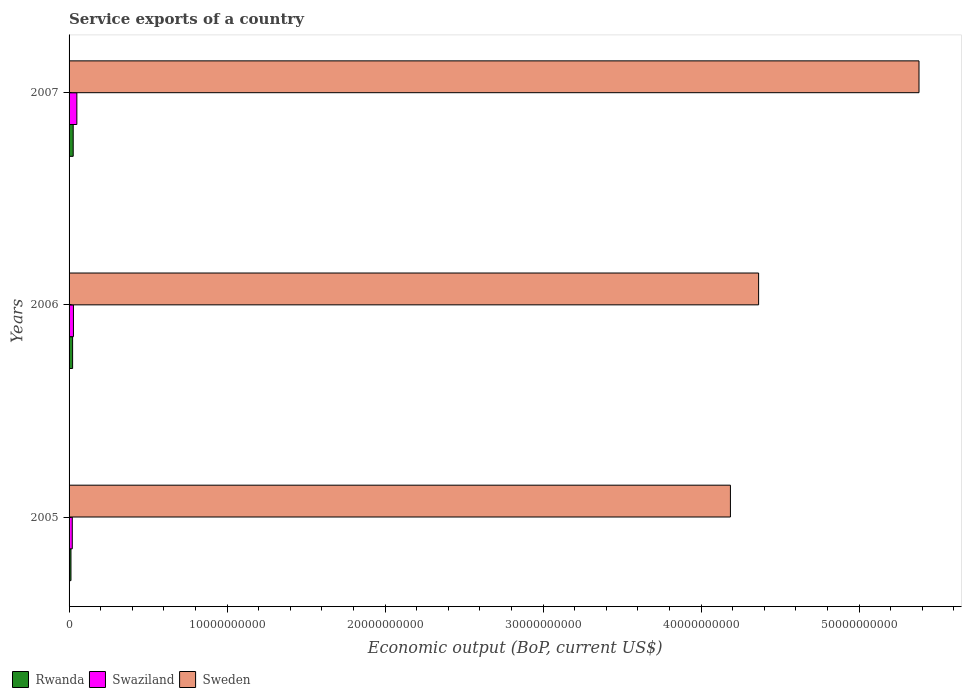How many bars are there on the 1st tick from the top?
Make the answer very short. 3. What is the label of the 2nd group of bars from the top?
Keep it short and to the point. 2006. What is the service exports in Swaziland in 2006?
Keep it short and to the point. 2.77e+08. Across all years, what is the maximum service exports in Swaziland?
Your answer should be very brief. 4.93e+08. Across all years, what is the minimum service exports in Sweden?
Provide a succinct answer. 4.19e+1. In which year was the service exports in Swaziland maximum?
Make the answer very short. 2007. In which year was the service exports in Sweden minimum?
Offer a very short reply. 2005. What is the total service exports in Rwanda in the graph?
Offer a very short reply. 6.06e+08. What is the difference between the service exports in Sweden in 2006 and that in 2007?
Keep it short and to the point. -1.02e+1. What is the difference between the service exports in Rwanda in 2006 and the service exports in Swaziland in 2005?
Give a very brief answer. 2.04e+07. What is the average service exports in Swaziland per year?
Keep it short and to the point. 3.25e+08. In the year 2006, what is the difference between the service exports in Swaziland and service exports in Rwanda?
Ensure brevity in your answer.  5.35e+07. In how many years, is the service exports in Rwanda greater than 26000000000 US$?
Your answer should be compact. 0. What is the ratio of the service exports in Sweden in 2005 to that in 2007?
Your answer should be compact. 0.78. Is the service exports in Rwanda in 2005 less than that in 2006?
Give a very brief answer. Yes. Is the difference between the service exports in Swaziland in 2006 and 2007 greater than the difference between the service exports in Rwanda in 2006 and 2007?
Your response must be concise. No. What is the difference between the highest and the second highest service exports in Sweden?
Offer a terse response. 1.02e+1. What is the difference between the highest and the lowest service exports in Rwanda?
Provide a succinct answer. 1.42e+08. What does the 3rd bar from the top in 2007 represents?
Ensure brevity in your answer.  Rwanda. Are all the bars in the graph horizontal?
Your answer should be compact. Yes. How many years are there in the graph?
Offer a terse response. 3. What is the difference between two consecutive major ticks on the X-axis?
Make the answer very short. 1.00e+1. Does the graph contain any zero values?
Ensure brevity in your answer.  No. Where does the legend appear in the graph?
Offer a very short reply. Bottom left. What is the title of the graph?
Your answer should be compact. Service exports of a country. Does "Other small states" appear as one of the legend labels in the graph?
Offer a very short reply. No. What is the label or title of the X-axis?
Your response must be concise. Economic output (BoP, current US$). What is the Economic output (BoP, current US$) of Rwanda in 2005?
Your response must be concise. 1.20e+08. What is the Economic output (BoP, current US$) of Swaziland in 2005?
Give a very brief answer. 2.03e+08. What is the Economic output (BoP, current US$) of Sweden in 2005?
Offer a very short reply. 4.19e+1. What is the Economic output (BoP, current US$) in Rwanda in 2006?
Your answer should be very brief. 2.24e+08. What is the Economic output (BoP, current US$) in Swaziland in 2006?
Provide a short and direct response. 2.77e+08. What is the Economic output (BoP, current US$) in Sweden in 2006?
Give a very brief answer. 4.36e+1. What is the Economic output (BoP, current US$) of Rwanda in 2007?
Provide a succinct answer. 2.62e+08. What is the Economic output (BoP, current US$) of Swaziland in 2007?
Provide a succinct answer. 4.93e+08. What is the Economic output (BoP, current US$) of Sweden in 2007?
Give a very brief answer. 5.38e+1. Across all years, what is the maximum Economic output (BoP, current US$) of Rwanda?
Your answer should be compact. 2.62e+08. Across all years, what is the maximum Economic output (BoP, current US$) in Swaziland?
Your response must be concise. 4.93e+08. Across all years, what is the maximum Economic output (BoP, current US$) of Sweden?
Your response must be concise. 5.38e+1. Across all years, what is the minimum Economic output (BoP, current US$) in Rwanda?
Ensure brevity in your answer.  1.20e+08. Across all years, what is the minimum Economic output (BoP, current US$) in Swaziland?
Offer a very short reply. 2.03e+08. Across all years, what is the minimum Economic output (BoP, current US$) of Sweden?
Your answer should be very brief. 4.19e+1. What is the total Economic output (BoP, current US$) of Rwanda in the graph?
Offer a terse response. 6.06e+08. What is the total Economic output (BoP, current US$) in Swaziland in the graph?
Offer a terse response. 9.74e+08. What is the total Economic output (BoP, current US$) in Sweden in the graph?
Provide a succinct answer. 1.39e+11. What is the difference between the Economic output (BoP, current US$) of Rwanda in 2005 and that in 2006?
Provide a succinct answer. -1.04e+08. What is the difference between the Economic output (BoP, current US$) in Swaziland in 2005 and that in 2006?
Keep it short and to the point. -7.39e+07. What is the difference between the Economic output (BoP, current US$) of Sweden in 2005 and that in 2006?
Your answer should be compact. -1.78e+09. What is the difference between the Economic output (BoP, current US$) of Rwanda in 2005 and that in 2007?
Offer a terse response. -1.42e+08. What is the difference between the Economic output (BoP, current US$) of Swaziland in 2005 and that in 2007?
Your response must be concise. -2.90e+08. What is the difference between the Economic output (BoP, current US$) in Sweden in 2005 and that in 2007?
Your response must be concise. -1.19e+1. What is the difference between the Economic output (BoP, current US$) of Rwanda in 2006 and that in 2007?
Offer a terse response. -3.82e+07. What is the difference between the Economic output (BoP, current US$) in Swaziland in 2006 and that in 2007?
Your response must be concise. -2.16e+08. What is the difference between the Economic output (BoP, current US$) of Sweden in 2006 and that in 2007?
Give a very brief answer. -1.02e+1. What is the difference between the Economic output (BoP, current US$) of Rwanda in 2005 and the Economic output (BoP, current US$) of Swaziland in 2006?
Give a very brief answer. -1.57e+08. What is the difference between the Economic output (BoP, current US$) of Rwanda in 2005 and the Economic output (BoP, current US$) of Sweden in 2006?
Make the answer very short. -4.35e+1. What is the difference between the Economic output (BoP, current US$) in Swaziland in 2005 and the Economic output (BoP, current US$) in Sweden in 2006?
Ensure brevity in your answer.  -4.34e+1. What is the difference between the Economic output (BoP, current US$) in Rwanda in 2005 and the Economic output (BoP, current US$) in Swaziland in 2007?
Give a very brief answer. -3.73e+08. What is the difference between the Economic output (BoP, current US$) in Rwanda in 2005 and the Economic output (BoP, current US$) in Sweden in 2007?
Your answer should be very brief. -5.37e+1. What is the difference between the Economic output (BoP, current US$) in Swaziland in 2005 and the Economic output (BoP, current US$) in Sweden in 2007?
Make the answer very short. -5.36e+1. What is the difference between the Economic output (BoP, current US$) of Rwanda in 2006 and the Economic output (BoP, current US$) of Swaziland in 2007?
Your answer should be very brief. -2.69e+08. What is the difference between the Economic output (BoP, current US$) of Rwanda in 2006 and the Economic output (BoP, current US$) of Sweden in 2007?
Keep it short and to the point. -5.36e+1. What is the difference between the Economic output (BoP, current US$) of Swaziland in 2006 and the Economic output (BoP, current US$) of Sweden in 2007?
Offer a very short reply. -5.35e+1. What is the average Economic output (BoP, current US$) of Rwanda per year?
Your answer should be compact. 2.02e+08. What is the average Economic output (BoP, current US$) of Swaziland per year?
Provide a succinct answer. 3.25e+08. What is the average Economic output (BoP, current US$) in Sweden per year?
Keep it short and to the point. 4.64e+1. In the year 2005, what is the difference between the Economic output (BoP, current US$) of Rwanda and Economic output (BoP, current US$) of Swaziland?
Offer a very short reply. -8.35e+07. In the year 2005, what is the difference between the Economic output (BoP, current US$) of Rwanda and Economic output (BoP, current US$) of Sweden?
Give a very brief answer. -4.17e+1. In the year 2005, what is the difference between the Economic output (BoP, current US$) of Swaziland and Economic output (BoP, current US$) of Sweden?
Your response must be concise. -4.17e+1. In the year 2006, what is the difference between the Economic output (BoP, current US$) in Rwanda and Economic output (BoP, current US$) in Swaziland?
Offer a terse response. -5.35e+07. In the year 2006, what is the difference between the Economic output (BoP, current US$) in Rwanda and Economic output (BoP, current US$) in Sweden?
Your answer should be very brief. -4.34e+1. In the year 2006, what is the difference between the Economic output (BoP, current US$) in Swaziland and Economic output (BoP, current US$) in Sweden?
Your response must be concise. -4.34e+1. In the year 2007, what is the difference between the Economic output (BoP, current US$) in Rwanda and Economic output (BoP, current US$) in Swaziland?
Keep it short and to the point. -2.31e+08. In the year 2007, what is the difference between the Economic output (BoP, current US$) of Rwanda and Economic output (BoP, current US$) of Sweden?
Your answer should be very brief. -5.35e+1. In the year 2007, what is the difference between the Economic output (BoP, current US$) of Swaziland and Economic output (BoP, current US$) of Sweden?
Make the answer very short. -5.33e+1. What is the ratio of the Economic output (BoP, current US$) in Rwanda in 2005 to that in 2006?
Your answer should be compact. 0.54. What is the ratio of the Economic output (BoP, current US$) in Swaziland in 2005 to that in 2006?
Provide a succinct answer. 0.73. What is the ratio of the Economic output (BoP, current US$) of Sweden in 2005 to that in 2006?
Make the answer very short. 0.96. What is the ratio of the Economic output (BoP, current US$) in Rwanda in 2005 to that in 2007?
Provide a succinct answer. 0.46. What is the ratio of the Economic output (BoP, current US$) in Swaziland in 2005 to that in 2007?
Your answer should be compact. 0.41. What is the ratio of the Economic output (BoP, current US$) of Sweden in 2005 to that in 2007?
Provide a succinct answer. 0.78. What is the ratio of the Economic output (BoP, current US$) of Rwanda in 2006 to that in 2007?
Ensure brevity in your answer.  0.85. What is the ratio of the Economic output (BoP, current US$) of Swaziland in 2006 to that in 2007?
Provide a short and direct response. 0.56. What is the ratio of the Economic output (BoP, current US$) of Sweden in 2006 to that in 2007?
Offer a terse response. 0.81. What is the difference between the highest and the second highest Economic output (BoP, current US$) of Rwanda?
Your response must be concise. 3.82e+07. What is the difference between the highest and the second highest Economic output (BoP, current US$) in Swaziland?
Provide a succinct answer. 2.16e+08. What is the difference between the highest and the second highest Economic output (BoP, current US$) in Sweden?
Your answer should be compact. 1.02e+1. What is the difference between the highest and the lowest Economic output (BoP, current US$) of Rwanda?
Your answer should be very brief. 1.42e+08. What is the difference between the highest and the lowest Economic output (BoP, current US$) in Swaziland?
Offer a very short reply. 2.90e+08. What is the difference between the highest and the lowest Economic output (BoP, current US$) of Sweden?
Give a very brief answer. 1.19e+1. 